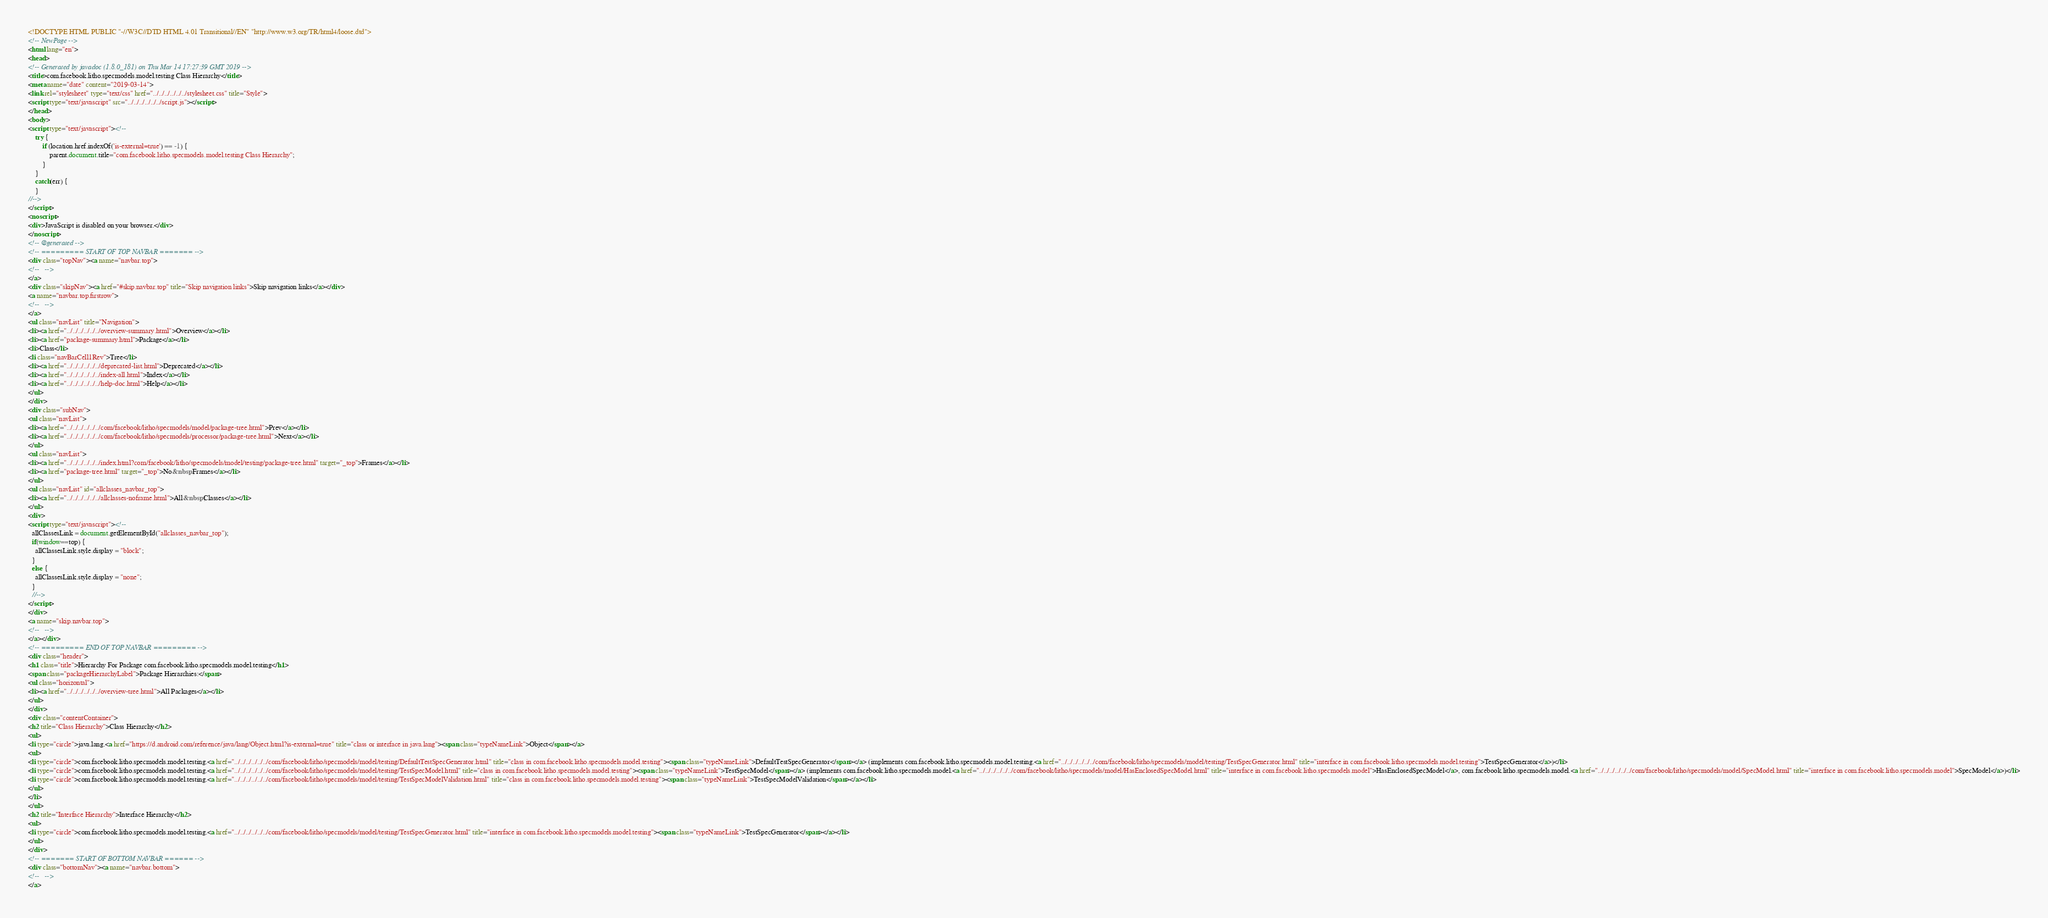Convert code to text. <code><loc_0><loc_0><loc_500><loc_500><_HTML_><!DOCTYPE HTML PUBLIC "-//W3C//DTD HTML 4.01 Transitional//EN" "http://www.w3.org/TR/html4/loose.dtd">
<!-- NewPage -->
<html lang="en">
<head>
<!-- Generated by javadoc (1.8.0_181) on Thu Mar 14 17:27:39 GMT 2019 -->
<title>com.facebook.litho.specmodels.model.testing Class Hierarchy</title>
<meta name="date" content="2019-03-14">
<link rel="stylesheet" type="text/css" href="../../../../../../stylesheet.css" title="Style">
<script type="text/javascript" src="../../../../../../script.js"></script>
</head>
<body>
<script type="text/javascript"><!--
    try {
        if (location.href.indexOf('is-external=true') == -1) {
            parent.document.title="com.facebook.litho.specmodels.model.testing Class Hierarchy";
        }
    }
    catch(err) {
    }
//-->
</script>
<noscript>
<div>JavaScript is disabled on your browser.</div>
</noscript>
<!-- @generated -->
<!-- ========= START OF TOP NAVBAR ======= -->
<div class="topNav"><a name="navbar.top">
<!--   -->
</a>
<div class="skipNav"><a href="#skip.navbar.top" title="Skip navigation links">Skip navigation links</a></div>
<a name="navbar.top.firstrow">
<!--   -->
</a>
<ul class="navList" title="Navigation">
<li><a href="../../../../../../overview-summary.html">Overview</a></li>
<li><a href="package-summary.html">Package</a></li>
<li>Class</li>
<li class="navBarCell1Rev">Tree</li>
<li><a href="../../../../../../deprecated-list.html">Deprecated</a></li>
<li><a href="../../../../../../index-all.html">Index</a></li>
<li><a href="../../../../../../help-doc.html">Help</a></li>
</ul>
</div>
<div class="subNav">
<ul class="navList">
<li><a href="../../../../../../com/facebook/litho/specmodels/model/package-tree.html">Prev</a></li>
<li><a href="../../../../../../com/facebook/litho/specmodels/processor/package-tree.html">Next</a></li>
</ul>
<ul class="navList">
<li><a href="../../../../../../index.html?com/facebook/litho/specmodels/model/testing/package-tree.html" target="_top">Frames</a></li>
<li><a href="package-tree.html" target="_top">No&nbsp;Frames</a></li>
</ul>
<ul class="navList" id="allclasses_navbar_top">
<li><a href="../../../../../../allclasses-noframe.html">All&nbsp;Classes</a></li>
</ul>
<div>
<script type="text/javascript"><!--
  allClassesLink = document.getElementById("allclasses_navbar_top");
  if(window==top) {
    allClassesLink.style.display = "block";
  }
  else {
    allClassesLink.style.display = "none";
  }
  //-->
</script>
</div>
<a name="skip.navbar.top">
<!--   -->
</a></div>
<!-- ========= END OF TOP NAVBAR ========= -->
<div class="header">
<h1 class="title">Hierarchy For Package com.facebook.litho.specmodels.model.testing</h1>
<span class="packageHierarchyLabel">Package Hierarchies:</span>
<ul class="horizontal">
<li><a href="../../../../../../overview-tree.html">All Packages</a></li>
</ul>
</div>
<div class="contentContainer">
<h2 title="Class Hierarchy">Class Hierarchy</h2>
<ul>
<li type="circle">java.lang.<a href="https://d.android.com/reference/java/lang/Object.html?is-external=true" title="class or interface in java.lang"><span class="typeNameLink">Object</span></a>
<ul>
<li type="circle">com.facebook.litho.specmodels.model.testing.<a href="../../../../../../com/facebook/litho/specmodels/model/testing/DefaultTestSpecGenerator.html" title="class in com.facebook.litho.specmodels.model.testing"><span class="typeNameLink">DefaultTestSpecGenerator</span></a> (implements com.facebook.litho.specmodels.model.testing.<a href="../../../../../../com/facebook/litho/specmodels/model/testing/TestSpecGenerator.html" title="interface in com.facebook.litho.specmodels.model.testing">TestSpecGenerator</a>)</li>
<li type="circle">com.facebook.litho.specmodels.model.testing.<a href="../../../../../../com/facebook/litho/specmodels/model/testing/TestSpecModel.html" title="class in com.facebook.litho.specmodels.model.testing"><span class="typeNameLink">TestSpecModel</span></a> (implements com.facebook.litho.specmodels.model.<a href="../../../../../../com/facebook/litho/specmodels/model/HasEnclosedSpecModel.html" title="interface in com.facebook.litho.specmodels.model">HasEnclosedSpecModel</a>, com.facebook.litho.specmodels.model.<a href="../../../../../../com/facebook/litho/specmodels/model/SpecModel.html" title="interface in com.facebook.litho.specmodels.model">SpecModel</a>)</li>
<li type="circle">com.facebook.litho.specmodels.model.testing.<a href="../../../../../../com/facebook/litho/specmodels/model/testing/TestSpecModelValidation.html" title="class in com.facebook.litho.specmodels.model.testing"><span class="typeNameLink">TestSpecModelValidation</span></a></li>
</ul>
</li>
</ul>
<h2 title="Interface Hierarchy">Interface Hierarchy</h2>
<ul>
<li type="circle">com.facebook.litho.specmodels.model.testing.<a href="../../../../../../com/facebook/litho/specmodels/model/testing/TestSpecGenerator.html" title="interface in com.facebook.litho.specmodels.model.testing"><span class="typeNameLink">TestSpecGenerator</span></a></li>
</ul>
</div>
<!-- ======= START OF BOTTOM NAVBAR ====== -->
<div class="bottomNav"><a name="navbar.bottom">
<!--   -->
</a></code> 